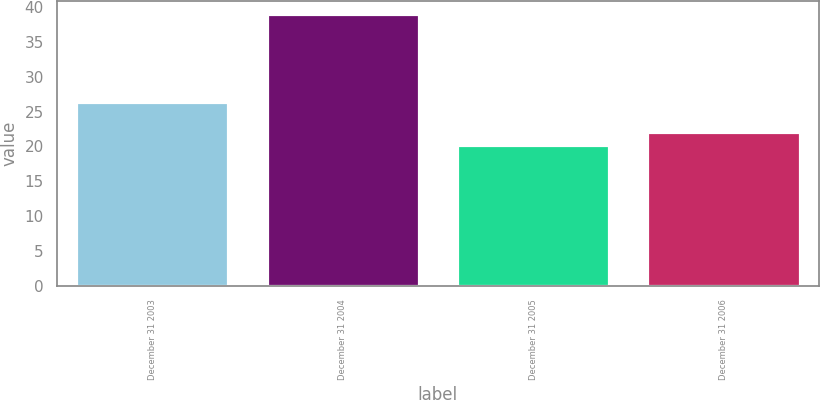<chart> <loc_0><loc_0><loc_500><loc_500><bar_chart><fcel>December 31 2003<fcel>December 31 2004<fcel>December 31 2005<fcel>December 31 2006<nl><fcel>26.4<fcel>38.9<fcel>20.2<fcel>22.07<nl></chart> 